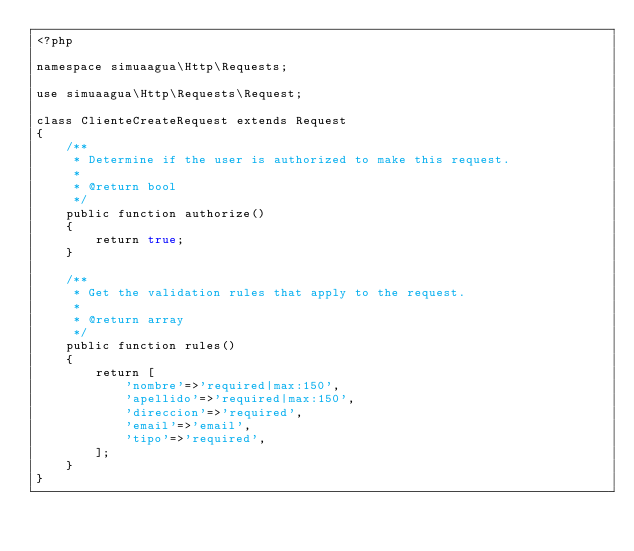Convert code to text. <code><loc_0><loc_0><loc_500><loc_500><_PHP_><?php

namespace simuaagua\Http\Requests;

use simuaagua\Http\Requests\Request;

class ClienteCreateRequest extends Request
{
    /**
     * Determine if the user is authorized to make this request.
     *
     * @return bool
     */
    public function authorize()
    {
        return true;
    }

    /**
     * Get the validation rules that apply to the request.
     *
     * @return array
     */
    public function rules()
    {
        return [
            'nombre'=>'required|max:150',
            'apellido'=>'required|max:150',
            'direccion'=>'required',
            'email'=>'email',
            'tipo'=>'required',
        ];
    }
}
</code> 